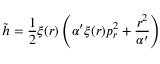Convert formula to latex. <formula><loc_0><loc_0><loc_500><loc_500>{ \tilde { h } } = \frac { 1 } { 2 } \xi ( r ) \left ( \alpha ^ { \prime } \xi ( r ) p _ { r } ^ { 2 } + \frac { r ^ { 2 } } { \alpha ^ { \prime } } \right )</formula> 